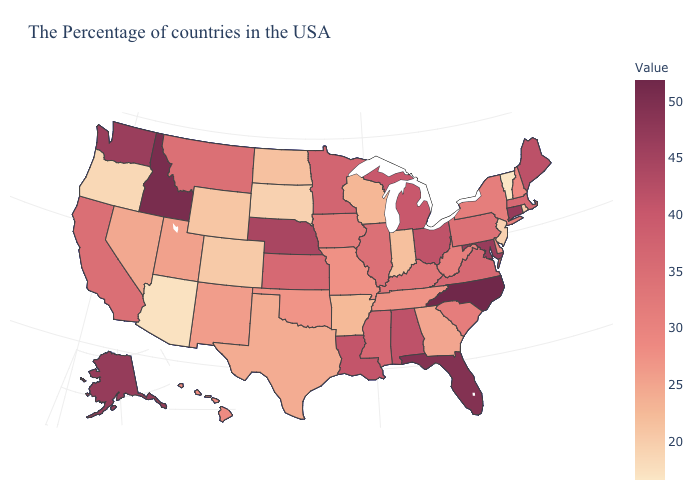Is the legend a continuous bar?
Answer briefly. Yes. Is the legend a continuous bar?
Short answer required. Yes. Among the states that border New Mexico , which have the lowest value?
Be succinct. Arizona. Among the states that border Georgia , which have the highest value?
Keep it brief. North Carolina. Is the legend a continuous bar?
Short answer required. Yes. 